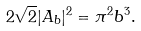Convert formula to latex. <formula><loc_0><loc_0><loc_500><loc_500>2 \sqrt { 2 } | A _ { b } | ^ { 2 } = \pi ^ { 2 } b ^ { 3 } .</formula> 